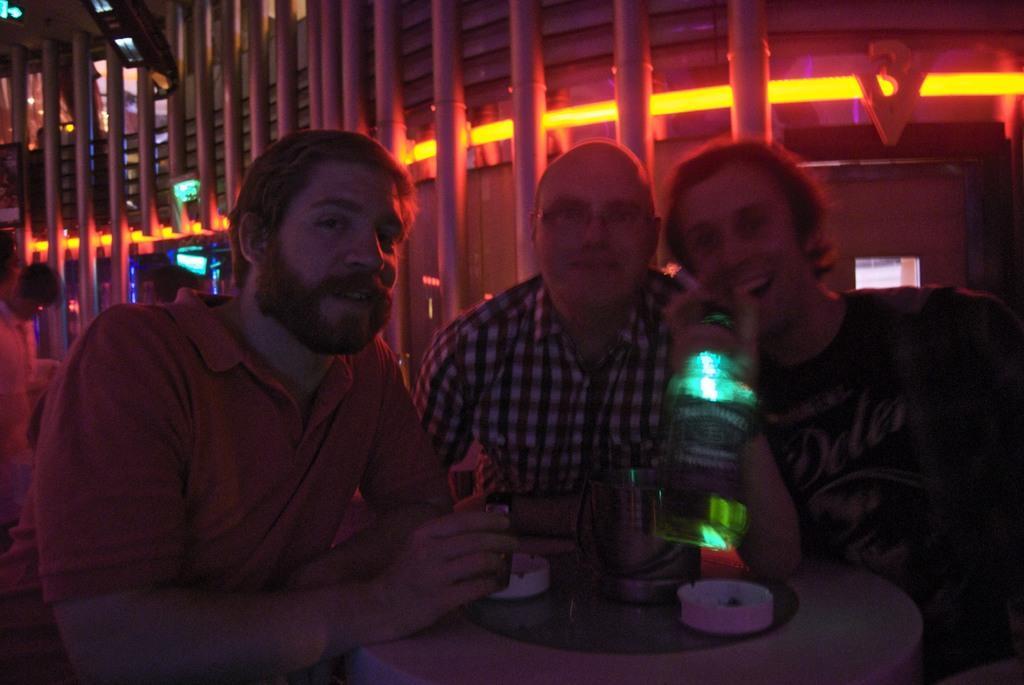In one or two sentences, can you explain what this image depicts? At the bottom of the image there is a table with few things on it. Behind the table there are three men. And there is a man holding a bottle in his hand. Behind them there are poles with lights. 